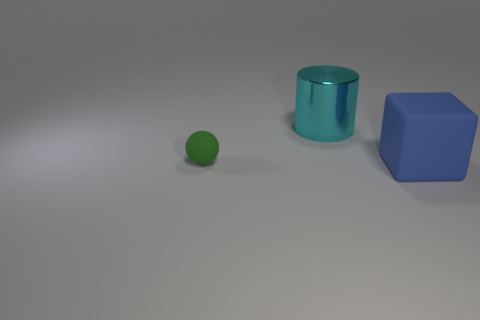Add 3 gray cubes. How many objects exist? 6 Subtract all cylinders. How many objects are left? 2 Subtract all cyan blocks. How many yellow spheres are left? 0 Subtract all green objects. Subtract all large rubber things. How many objects are left? 1 Add 1 large cyan objects. How many large cyan objects are left? 2 Add 1 large yellow metal spheres. How many large yellow metal spheres exist? 1 Subtract 0 purple cylinders. How many objects are left? 3 Subtract all purple cylinders. Subtract all cyan cubes. How many cylinders are left? 1 